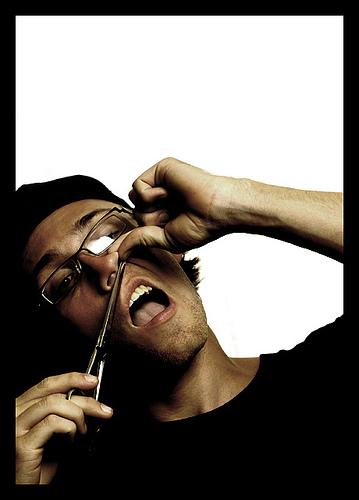What is the man holding in his right hand?
Be succinct. Scissors. What is the man doing?
Short answer required. Trimming nose hair. Is he giving himself a nose job?
Short answer required. No. 